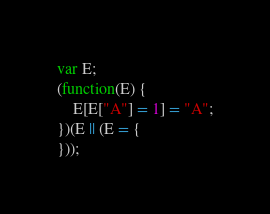<code> <loc_0><loc_0><loc_500><loc_500><_JavaScript_>var E;
(function(E) {
    E[E["A"] = 1] = "A";
})(E || (E = {
}));
</code> 